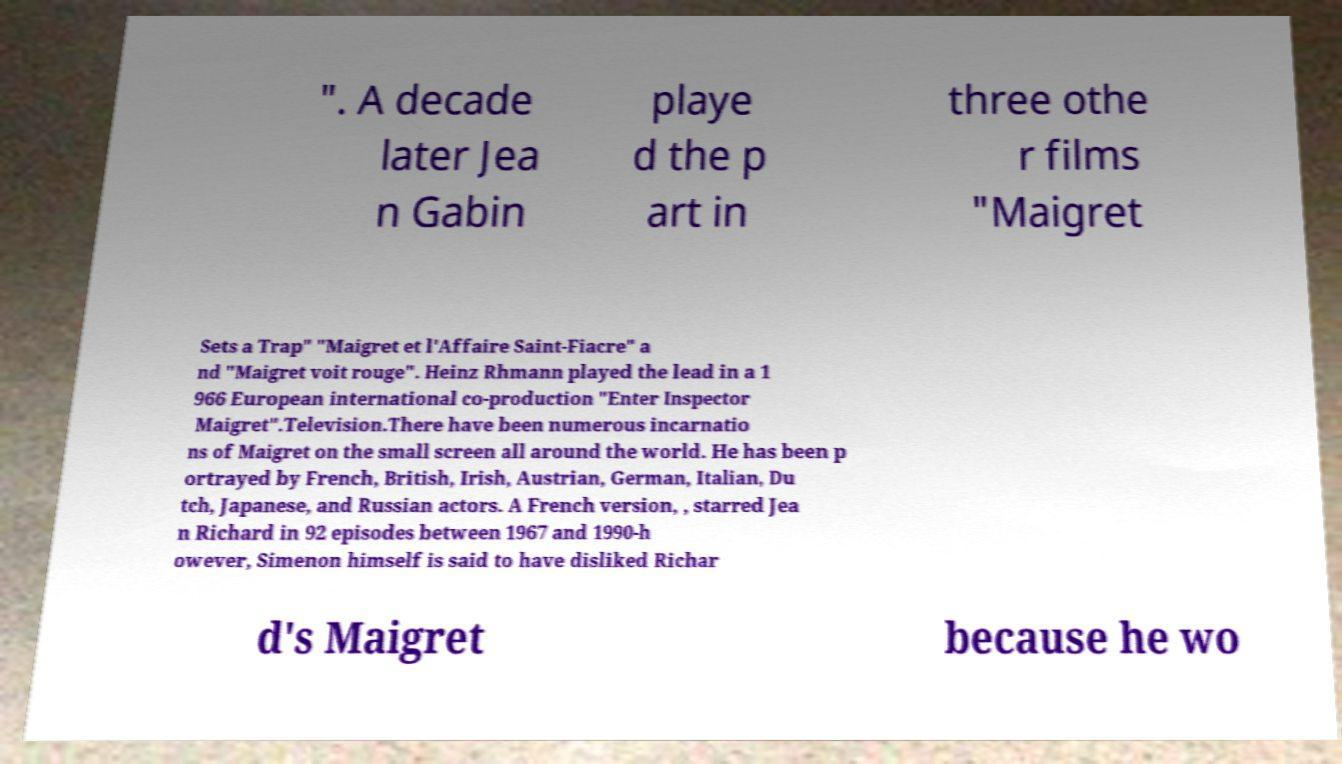I need the written content from this picture converted into text. Can you do that? ". A decade later Jea n Gabin playe d the p art in three othe r films "Maigret Sets a Trap" "Maigret et l'Affaire Saint-Fiacre" a nd "Maigret voit rouge". Heinz Rhmann played the lead in a 1 966 European international co-production "Enter Inspector Maigret".Television.There have been numerous incarnatio ns of Maigret on the small screen all around the world. He has been p ortrayed by French, British, Irish, Austrian, German, Italian, Du tch, Japanese, and Russian actors. A French version, , starred Jea n Richard in 92 episodes between 1967 and 1990-h owever, Simenon himself is said to have disliked Richar d's Maigret because he wo 